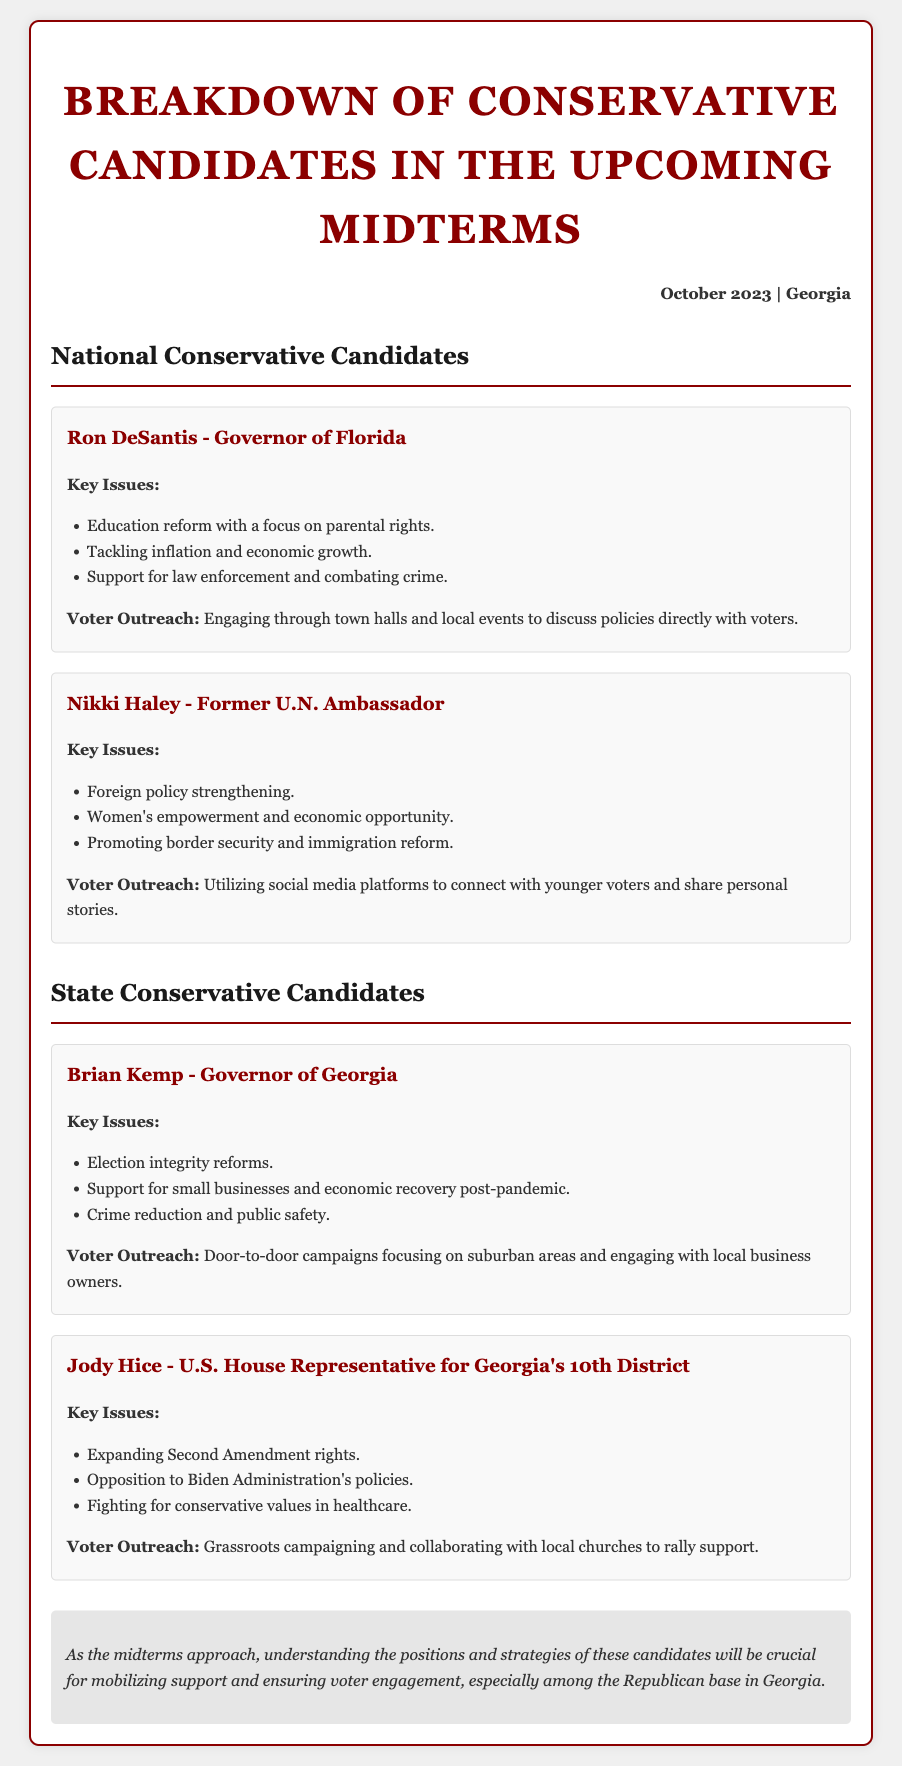What are the key issues for Ron DeSantis? The key issues for Ron DeSantis include education reform with a focus on parental rights, tackling inflation and economic growth, and support for law enforcement and combating crime.
Answer: education reform, tackling inflation, support for law enforcement What is Nikki Haley's role? Nikki Haley is identified as the Former U.N. Ambassador in the document.
Answer: Former U.N. Ambassador What voter outreach strategy does Brian Kemp utilize? Brian Kemp's voter outreach strategy focuses on door-to-door campaigns, targeting suburban areas, and engaging with local business owners.
Answer: Door-to-door campaigns How many key issues are listed for Jody Hice? The document lists three key issues for Jody Hice.
Answer: three Which candidate is focused on foreign policy? The candidate focused on foreign policy is Nikki Haley.
Answer: Nikki Haley What date is indicated at the top of the document? The date indicated at the top of the document is October 2023.
Answer: October 2023 Which candidate supports small businesses? Brian Kemp supports small businesses according to the document.
Answer: Brian Kemp What type of campaigning does Jody Hice engage in? Jody Hice engages in grassroots campaigning as stated in the document.
Answer: grassroots campaigning What is the conclusion about the candidates? The conclusion highlights the importance of understanding candidates' positions and strategies for mobilizing support in Georgia.
Answer: Understanding positions and strategies is crucial for mobilizing support 